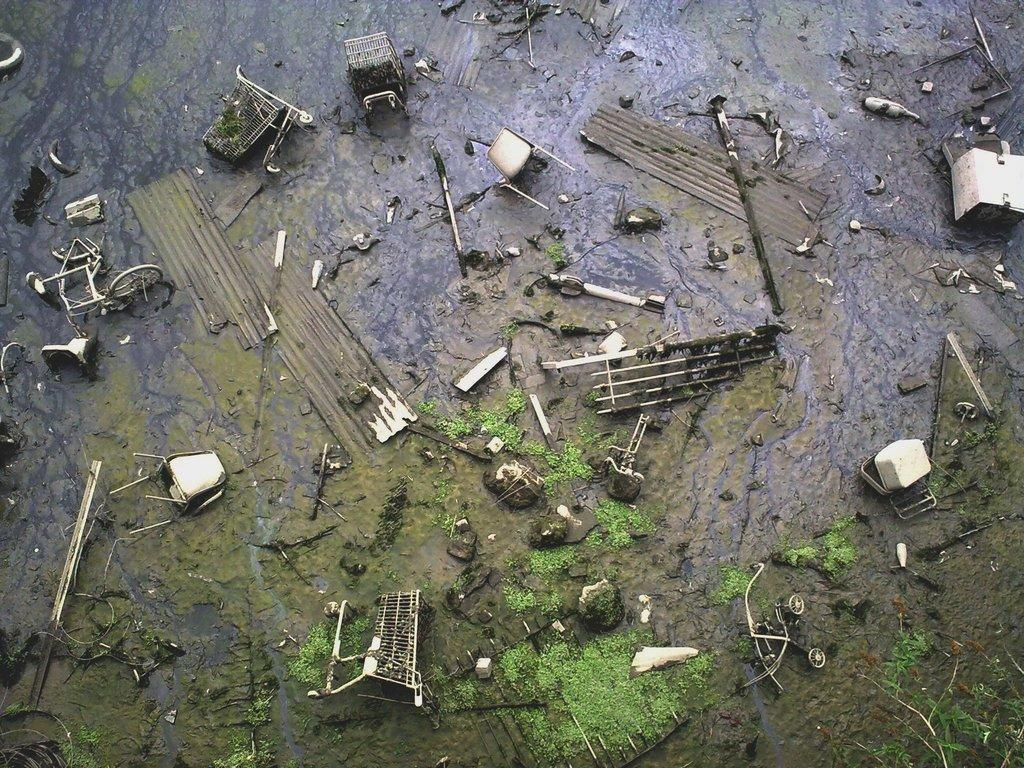What can be seen on the wet mud in the image? There are wastage particles on the wet mud in the image. What type of plant life is present on the surface? Algae is present on the surface. What type of furniture can be seen in the image? Chairs are present in the image. What type of material is used for the objects visible in the image? Metal objects are visible in the image. What type of transportation is present in the image? A bicycle is present in the image. What other objects can be seen in the image? Other objects are present in the image. What type of food is being used as a decoration in the image? There is no food present in the image that is being used as a decoration. What type of amusement is present in the image? There is no amusement present in the image. 